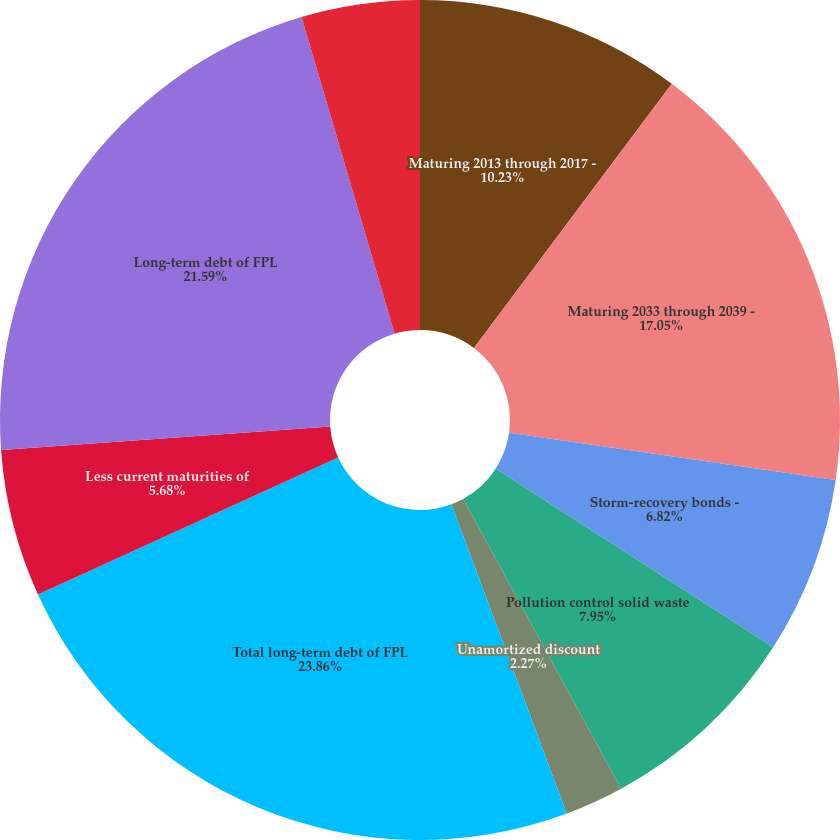<chart> <loc_0><loc_0><loc_500><loc_500><pie_chart><fcel>Maturing 2013 through 2017 -<fcel>Maturing 2033 through 2039 -<fcel>Storm-recovery bonds -<fcel>Pollution control solid waste<fcel>Unamortized discount<fcel>Total long-term debt of FPL<fcel>Less current maturities of<fcel>Long-term debt of FPL<fcel>Debentures - maturing 2011<nl><fcel>10.23%<fcel>17.05%<fcel>6.82%<fcel>7.95%<fcel>2.27%<fcel>23.86%<fcel>5.68%<fcel>21.59%<fcel>4.55%<nl></chart> 